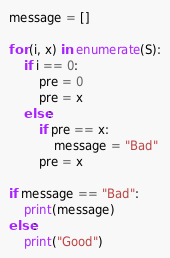<code> <loc_0><loc_0><loc_500><loc_500><_Python_>message = []

for (i, x) in enumerate(S):
    if i == 0:
        pre = 0
        pre = x
    else:
        if pre == x:
            message = "Bad"
        pre = x
            
if message == "Bad":
    print(message)
else:
    print("Good")</code> 